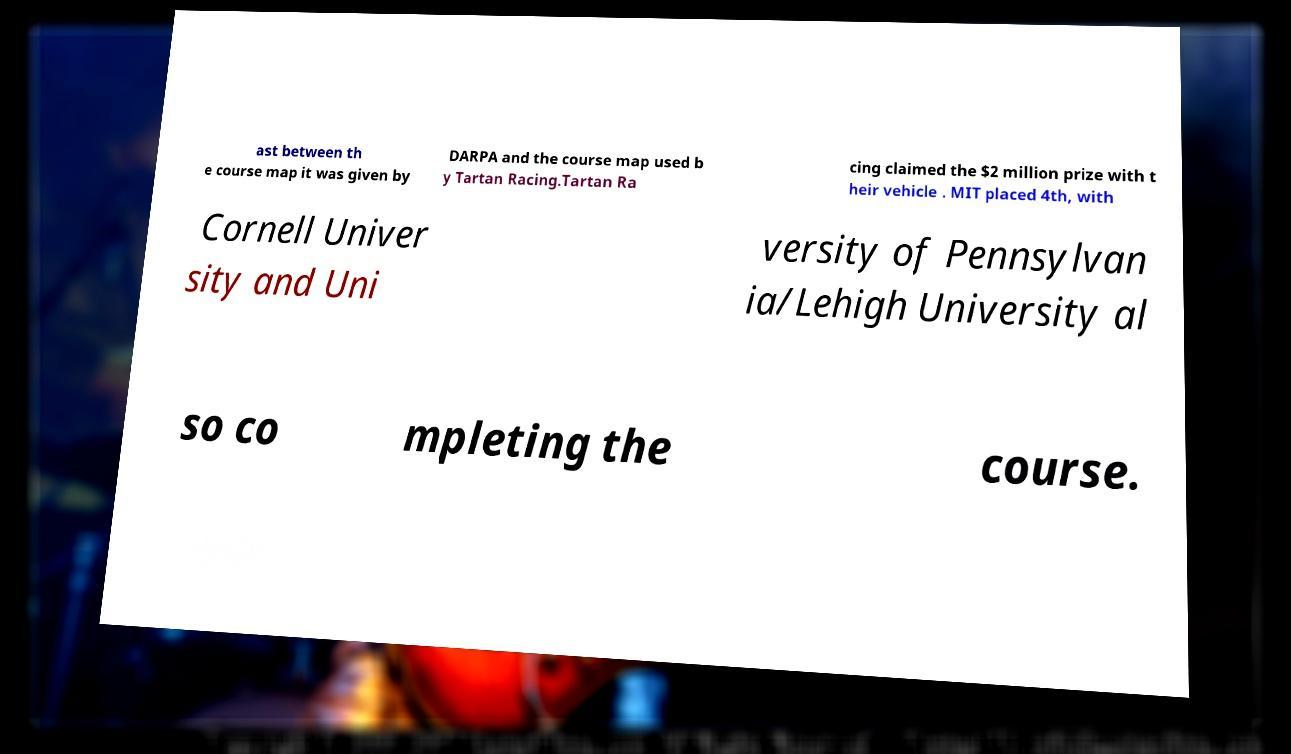There's text embedded in this image that I need extracted. Can you transcribe it verbatim? ast between th e course map it was given by DARPA and the course map used b y Tartan Racing.Tartan Ra cing claimed the $2 million prize with t heir vehicle . MIT placed 4th, with Cornell Univer sity and Uni versity of Pennsylvan ia/Lehigh University al so co mpleting the course. 